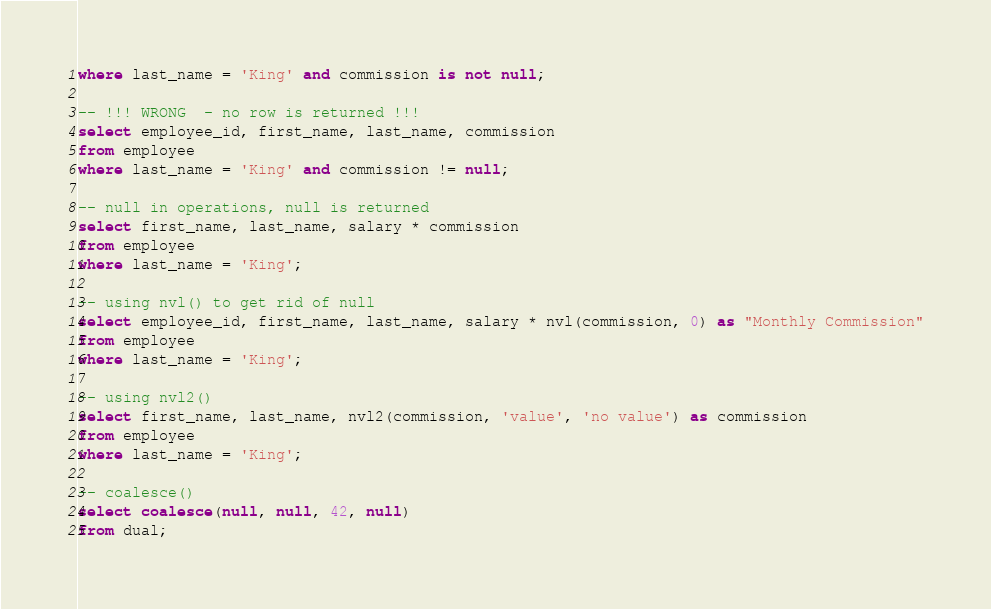<code> <loc_0><loc_0><loc_500><loc_500><_SQL_>where last_name = 'King' and commission is not null;

-- !!! WRONG  - no row is returned !!!
select employee_id, first_name, last_name, commission
from employee
where last_name = 'King' and commission != null;

-- null in operations, null is returned
select first_name, last_name, salary * commission
from employee
where last_name = 'King';

-- using nvl() to get rid of null
select employee_id, first_name, last_name, salary * nvl(commission, 0) as "Monthly Commission"
from employee
where last_name = 'King';

-- using nvl2()
select first_name, last_name, nvl2(commission, 'value', 'no value') as commission
from employee
where last_name = 'King';

-- coalesce()
select coalesce(null, null, 42, null)
from dual;
</code> 